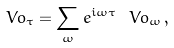Convert formula to latex. <formula><loc_0><loc_0><loc_500><loc_500>\ V o _ { \tau } = \sum _ { \omega } e ^ { i \omega \tau } \ V o _ { \omega } \, ,</formula> 